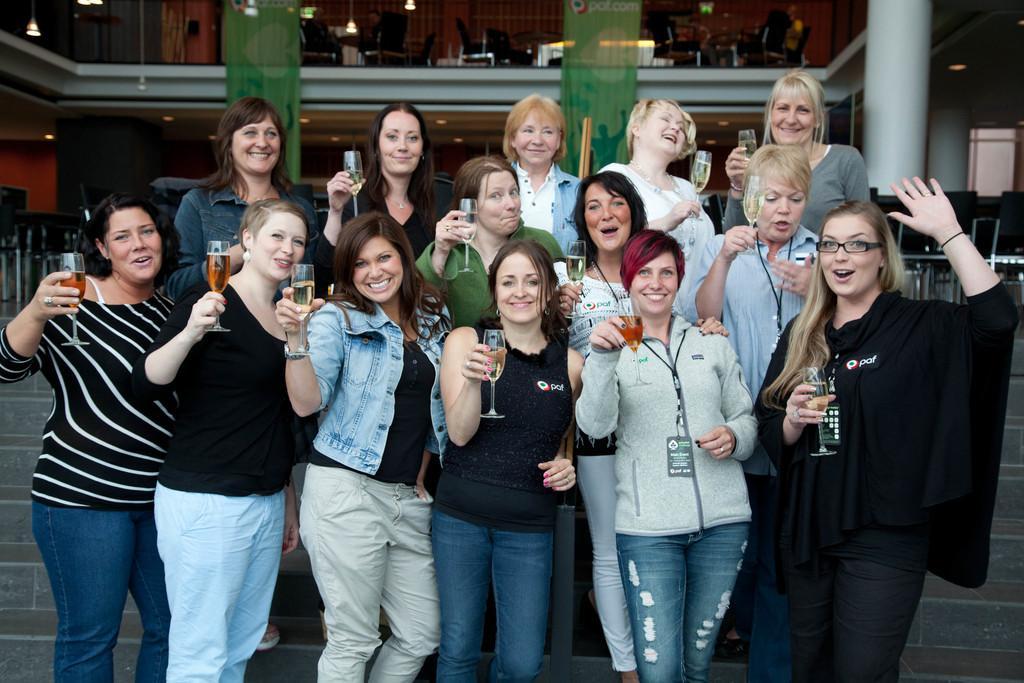In one or two sentences, can you explain what this image depicts? In this image, we can see some people standing and they are holding glasses, in the background we can see two green color posters, at the right side there is a white color pillar. 